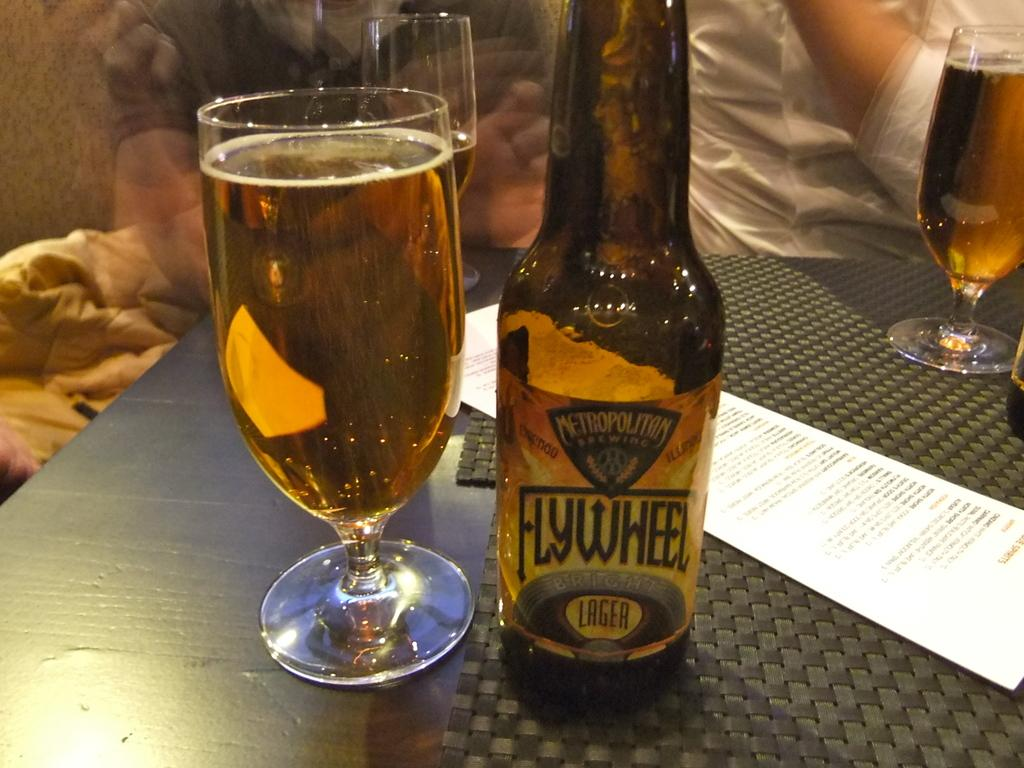Provide a one-sentence caption for the provided image. A bootle of Flywheel lager is poured into a glass sitting next to it. 